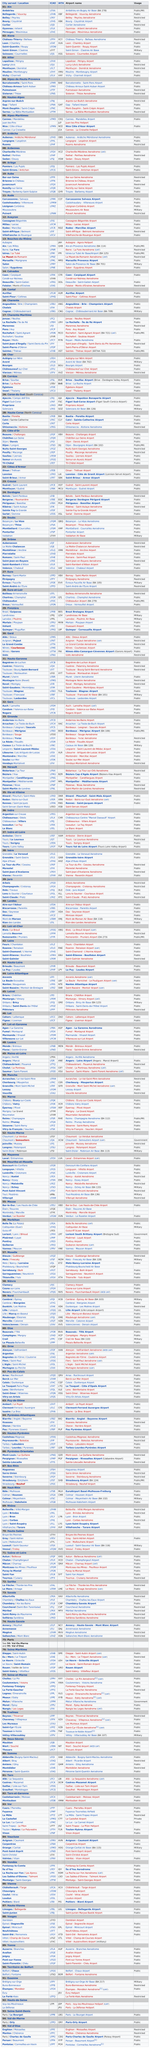Mention a couple of crucial points in this snapshot. The Nîmes-Alès-Camargue-Cévennes Airport serves the cities of Nîmes and Garons. The IATA code for the ICAO code LFHN is XBF. Ambérieu-en-Bugey Air Base is the airport that serves the town of Ambérieu, it is also known as Ambérieu Air Base. 